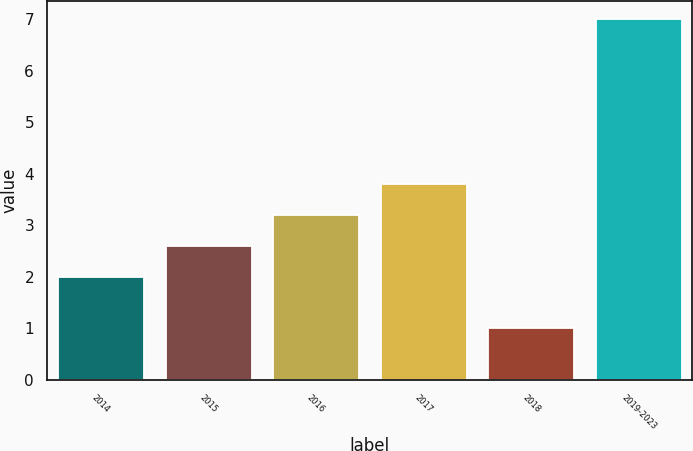Convert chart. <chart><loc_0><loc_0><loc_500><loc_500><bar_chart><fcel>2014<fcel>2015<fcel>2016<fcel>2017<fcel>2018<fcel>2019-2023<nl><fcel>2<fcel>2.6<fcel>3.2<fcel>3.8<fcel>1<fcel>7<nl></chart> 